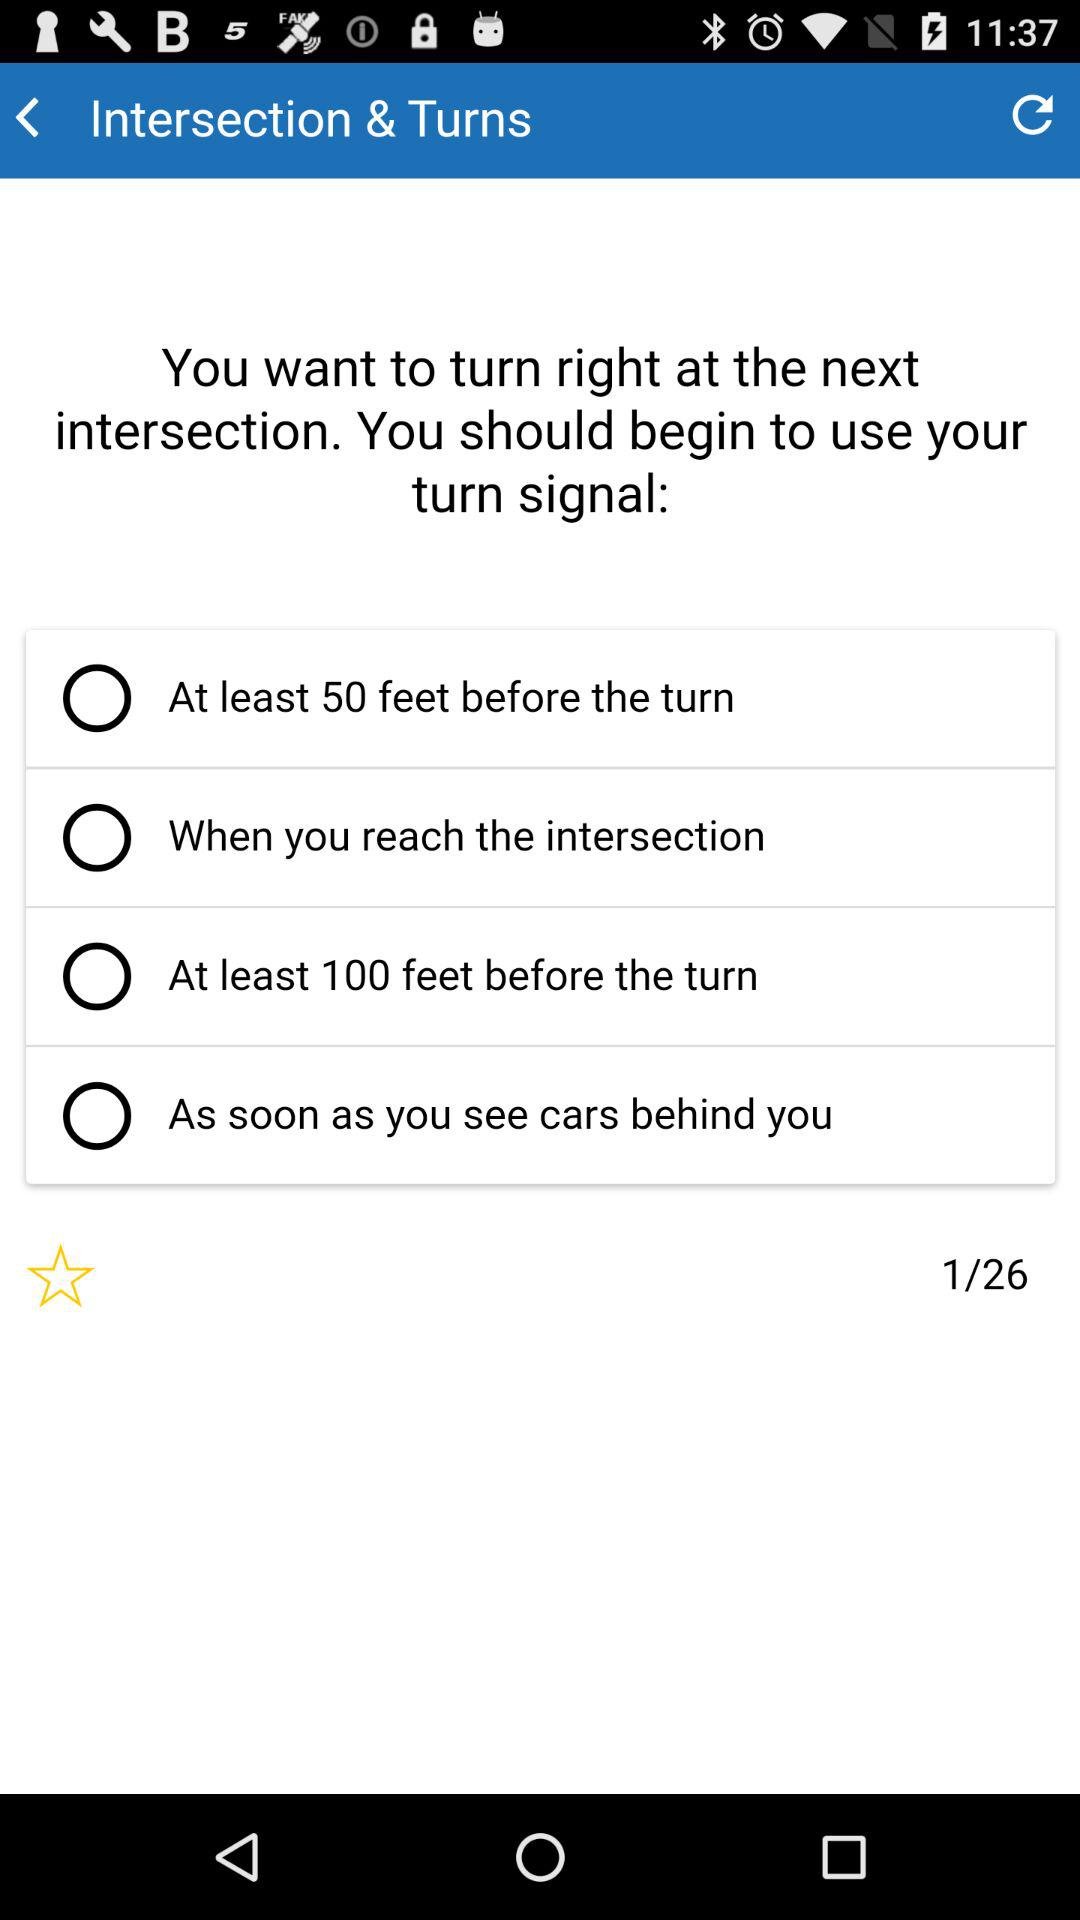Which question am I at? You are at the first question. 